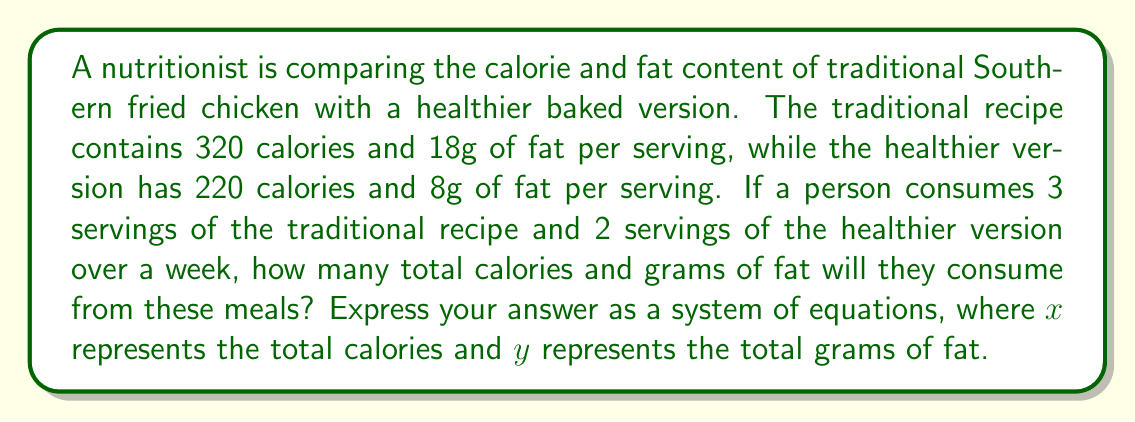What is the answer to this math problem? Let's break this down step-by-step:

1. Define variables:
   $x$ = total calories
   $y$ = total grams of fat

2. Calculate calories for traditional recipe:
   3 servings × 320 calories/serving = 960 calories

3. Calculate calories for healthier version:
   2 servings × 220 calories/serving = 440 calories

4. Total calories equation:
   $x = 960 + 440 = 1400$

5. Calculate fat for traditional recipe:
   3 servings × 18g fat/serving = 54g fat

6. Calculate fat for healthier version:
   2 servings × 8g fat/serving = 16g fat

7. Total fat equation:
   $y = 54 + 16 = 70$

8. Express as a system of equations:
   $$\begin{cases}
   x = 1400 \\
   y = 70
   \end{cases}$$

This system represents the total calories ($x$) and total grams of fat ($y$) consumed from these meals over a week.
Answer: $$\begin{cases}
x = 1400 \\
y = 70
\end{cases}$$ 